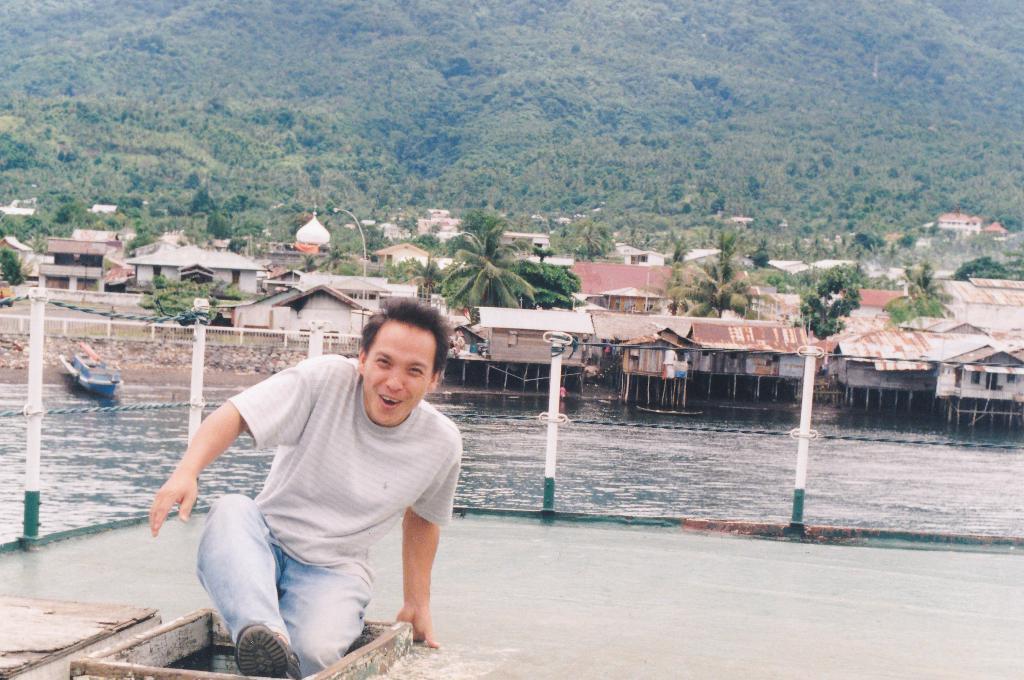In one or two sentences, can you explain what this image depicts? In this image I can see houses and trees lake visible in the middle and I can see a person visible in the foreground ,at the top I can see the hill. In the middle I can see poles. 